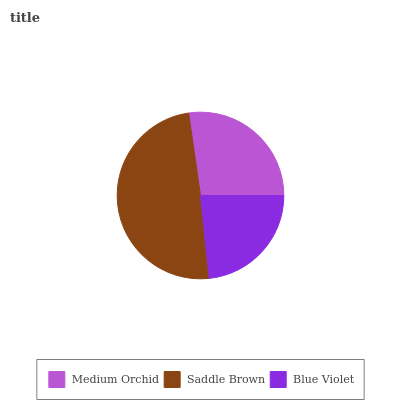Is Blue Violet the minimum?
Answer yes or no. Yes. Is Saddle Brown the maximum?
Answer yes or no. Yes. Is Saddle Brown the minimum?
Answer yes or no. No. Is Blue Violet the maximum?
Answer yes or no. No. Is Saddle Brown greater than Blue Violet?
Answer yes or no. Yes. Is Blue Violet less than Saddle Brown?
Answer yes or no. Yes. Is Blue Violet greater than Saddle Brown?
Answer yes or no. No. Is Saddle Brown less than Blue Violet?
Answer yes or no. No. Is Medium Orchid the high median?
Answer yes or no. Yes. Is Medium Orchid the low median?
Answer yes or no. Yes. Is Blue Violet the high median?
Answer yes or no. No. Is Saddle Brown the low median?
Answer yes or no. No. 